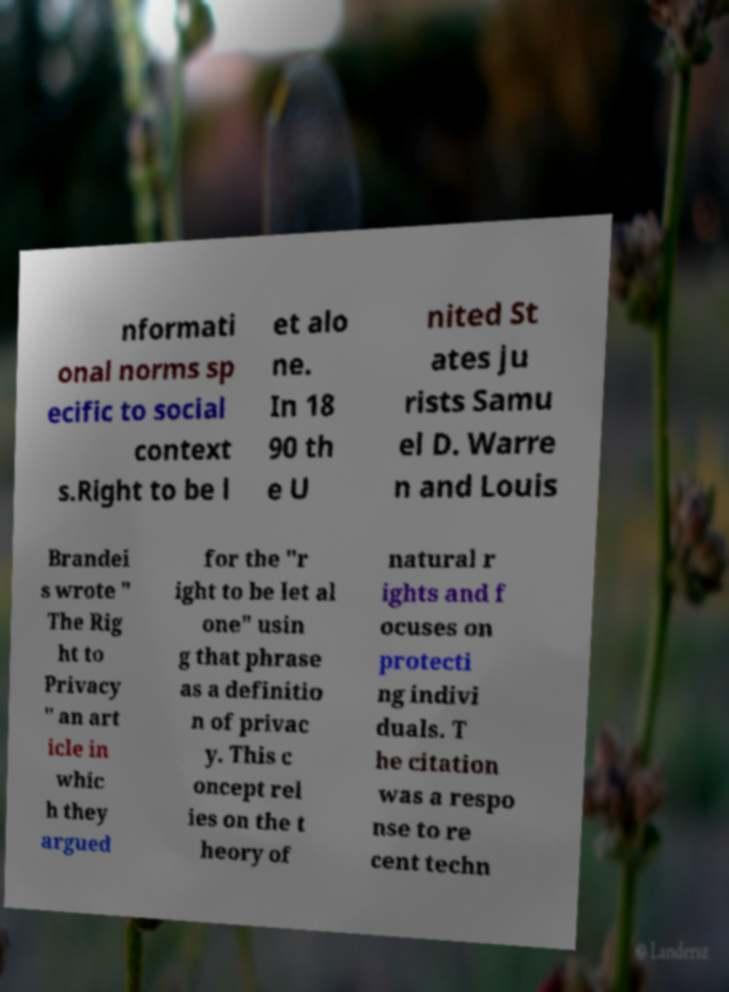I need the written content from this picture converted into text. Can you do that? nformati onal norms sp ecific to social context s.Right to be l et alo ne. In 18 90 th e U nited St ates ju rists Samu el D. Warre n and Louis Brandei s wrote " The Rig ht to Privacy " an art icle in whic h they argued for the "r ight to be let al one" usin g that phrase as a definitio n of privac y. This c oncept rel ies on the t heory of natural r ights and f ocuses on protecti ng indivi duals. T he citation was a respo nse to re cent techn 